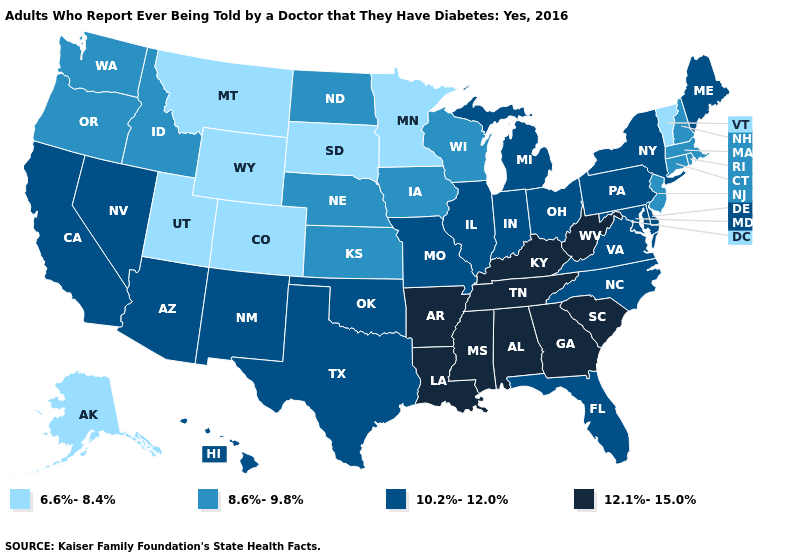Does the first symbol in the legend represent the smallest category?
Give a very brief answer. Yes. Does the map have missing data?
Answer briefly. No. Does Vermont have the lowest value in the Northeast?
Short answer required. Yes. Is the legend a continuous bar?
Concise answer only. No. Name the states that have a value in the range 6.6%-8.4%?
Concise answer only. Alaska, Colorado, Minnesota, Montana, South Dakota, Utah, Vermont, Wyoming. Name the states that have a value in the range 6.6%-8.4%?
Answer briefly. Alaska, Colorado, Minnesota, Montana, South Dakota, Utah, Vermont, Wyoming. Name the states that have a value in the range 12.1%-15.0%?
Answer briefly. Alabama, Arkansas, Georgia, Kentucky, Louisiana, Mississippi, South Carolina, Tennessee, West Virginia. Among the states that border Kentucky , which have the lowest value?
Write a very short answer. Illinois, Indiana, Missouri, Ohio, Virginia. Does the first symbol in the legend represent the smallest category?
Be succinct. Yes. What is the value of Arkansas?
Concise answer only. 12.1%-15.0%. Which states hav the highest value in the MidWest?
Answer briefly. Illinois, Indiana, Michigan, Missouri, Ohio. What is the value of Mississippi?
Quick response, please. 12.1%-15.0%. Name the states that have a value in the range 8.6%-9.8%?
Write a very short answer. Connecticut, Idaho, Iowa, Kansas, Massachusetts, Nebraska, New Hampshire, New Jersey, North Dakota, Oregon, Rhode Island, Washington, Wisconsin. Does Pennsylvania have the same value as Rhode Island?
Short answer required. No. What is the value of Vermont?
Answer briefly. 6.6%-8.4%. 